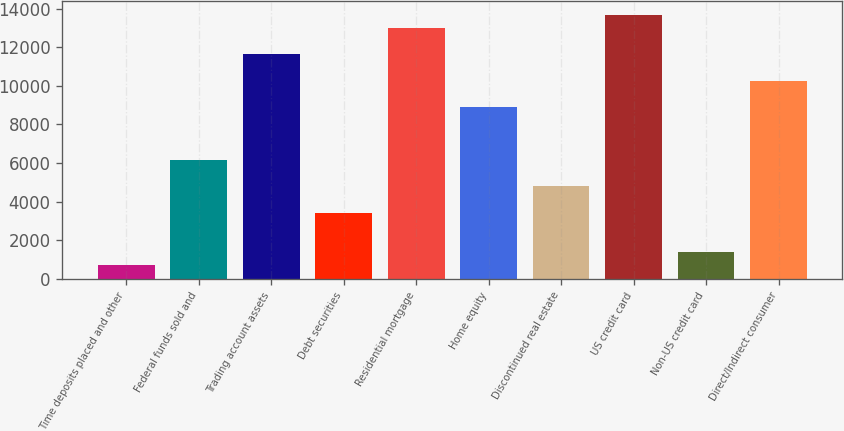Convert chart to OTSL. <chart><loc_0><loc_0><loc_500><loc_500><bar_chart><fcel>Time deposits placed and other<fcel>Federal funds sold and<fcel>Trading account assets<fcel>Debt securities<fcel>Residential mortgage<fcel>Home equity<fcel>Discontinued real estate<fcel>US credit card<fcel>Non-US credit card<fcel>Direct/Indirect consumer<nl><fcel>698.5<fcel>6166.5<fcel>11634.5<fcel>3432.5<fcel>13001.5<fcel>8900.5<fcel>4799.5<fcel>13685<fcel>1382<fcel>10267.5<nl></chart> 